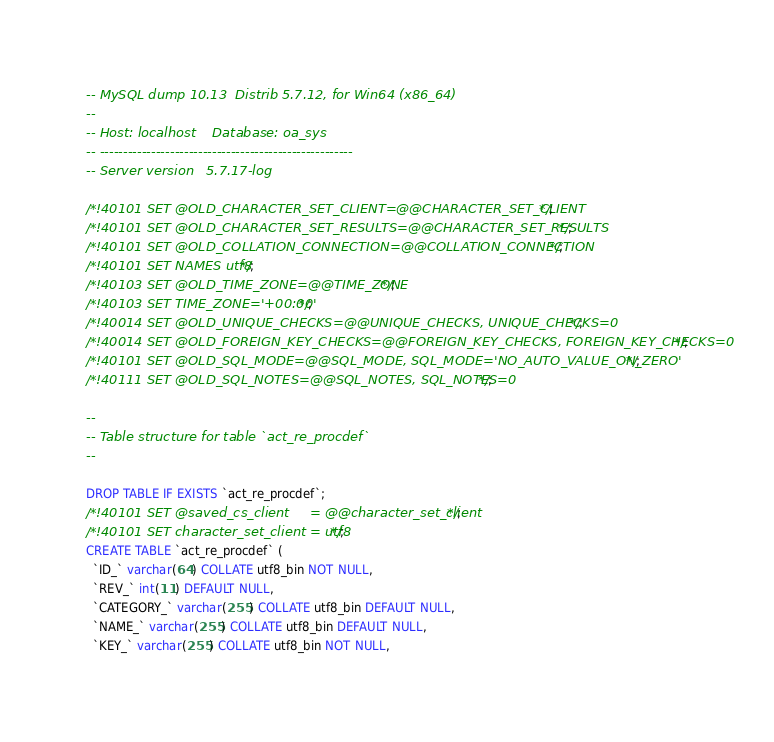Convert code to text. <code><loc_0><loc_0><loc_500><loc_500><_SQL_>-- MySQL dump 10.13  Distrib 5.7.12, for Win64 (x86_64)
--
-- Host: localhost    Database: oa_sys
-- ------------------------------------------------------
-- Server version	5.7.17-log

/*!40101 SET @OLD_CHARACTER_SET_CLIENT=@@CHARACTER_SET_CLIENT */;
/*!40101 SET @OLD_CHARACTER_SET_RESULTS=@@CHARACTER_SET_RESULTS */;
/*!40101 SET @OLD_COLLATION_CONNECTION=@@COLLATION_CONNECTION */;
/*!40101 SET NAMES utf8 */;
/*!40103 SET @OLD_TIME_ZONE=@@TIME_ZONE */;
/*!40103 SET TIME_ZONE='+00:00' */;
/*!40014 SET @OLD_UNIQUE_CHECKS=@@UNIQUE_CHECKS, UNIQUE_CHECKS=0 */;
/*!40014 SET @OLD_FOREIGN_KEY_CHECKS=@@FOREIGN_KEY_CHECKS, FOREIGN_KEY_CHECKS=0 */;
/*!40101 SET @OLD_SQL_MODE=@@SQL_MODE, SQL_MODE='NO_AUTO_VALUE_ON_ZERO' */;
/*!40111 SET @OLD_SQL_NOTES=@@SQL_NOTES, SQL_NOTES=0 */;

--
-- Table structure for table `act_re_procdef`
--

DROP TABLE IF EXISTS `act_re_procdef`;
/*!40101 SET @saved_cs_client     = @@character_set_client */;
/*!40101 SET character_set_client = utf8 */;
CREATE TABLE `act_re_procdef` (
  `ID_` varchar(64) COLLATE utf8_bin NOT NULL,
  `REV_` int(11) DEFAULT NULL,
  `CATEGORY_` varchar(255) COLLATE utf8_bin DEFAULT NULL,
  `NAME_` varchar(255) COLLATE utf8_bin DEFAULT NULL,
  `KEY_` varchar(255) COLLATE utf8_bin NOT NULL,</code> 